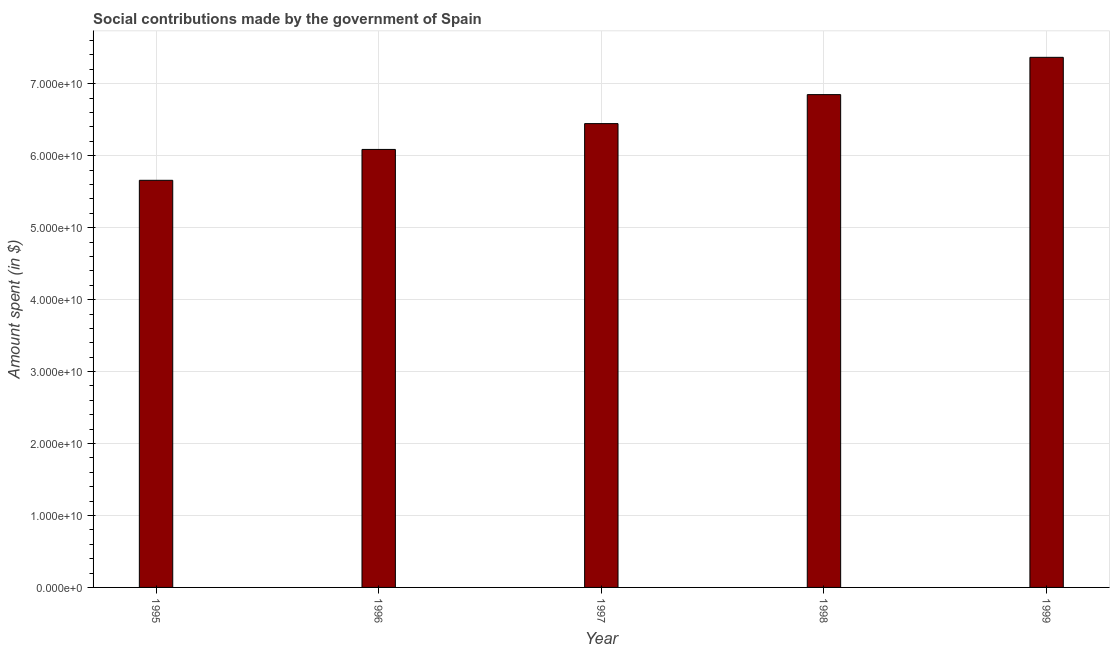What is the title of the graph?
Provide a short and direct response. Social contributions made by the government of Spain. What is the label or title of the Y-axis?
Provide a short and direct response. Amount spent (in $). What is the amount spent in making social contributions in 1998?
Offer a very short reply. 6.85e+1. Across all years, what is the maximum amount spent in making social contributions?
Your answer should be compact. 7.37e+1. Across all years, what is the minimum amount spent in making social contributions?
Your answer should be very brief. 5.66e+1. In which year was the amount spent in making social contributions maximum?
Provide a short and direct response. 1999. In which year was the amount spent in making social contributions minimum?
Keep it short and to the point. 1995. What is the sum of the amount spent in making social contributions?
Keep it short and to the point. 3.24e+11. What is the difference between the amount spent in making social contributions in 1998 and 1999?
Ensure brevity in your answer.  -5.18e+09. What is the average amount spent in making social contributions per year?
Provide a short and direct response. 6.48e+1. What is the median amount spent in making social contributions?
Your answer should be very brief. 6.45e+1. Do a majority of the years between 1999 and 1995 (inclusive) have amount spent in making social contributions greater than 54000000000 $?
Offer a terse response. Yes. What is the ratio of the amount spent in making social contributions in 1995 to that in 1997?
Provide a succinct answer. 0.88. Is the amount spent in making social contributions in 1996 less than that in 1998?
Offer a terse response. Yes. What is the difference between the highest and the second highest amount spent in making social contributions?
Your response must be concise. 5.18e+09. What is the difference between the highest and the lowest amount spent in making social contributions?
Keep it short and to the point. 1.71e+1. In how many years, is the amount spent in making social contributions greater than the average amount spent in making social contributions taken over all years?
Your answer should be very brief. 2. How many bars are there?
Keep it short and to the point. 5. Are all the bars in the graph horizontal?
Your answer should be very brief. No. What is the difference between two consecutive major ticks on the Y-axis?
Provide a short and direct response. 1.00e+1. Are the values on the major ticks of Y-axis written in scientific E-notation?
Your answer should be very brief. Yes. What is the Amount spent (in $) in 1995?
Your answer should be compact. 5.66e+1. What is the Amount spent (in $) of 1996?
Provide a short and direct response. 6.09e+1. What is the Amount spent (in $) in 1997?
Provide a succinct answer. 6.45e+1. What is the Amount spent (in $) in 1998?
Your answer should be compact. 6.85e+1. What is the Amount spent (in $) of 1999?
Offer a very short reply. 7.37e+1. What is the difference between the Amount spent (in $) in 1995 and 1996?
Ensure brevity in your answer.  -4.29e+09. What is the difference between the Amount spent (in $) in 1995 and 1997?
Ensure brevity in your answer.  -7.88e+09. What is the difference between the Amount spent (in $) in 1995 and 1998?
Provide a succinct answer. -1.19e+1. What is the difference between the Amount spent (in $) in 1995 and 1999?
Give a very brief answer. -1.71e+1. What is the difference between the Amount spent (in $) in 1996 and 1997?
Provide a short and direct response. -3.59e+09. What is the difference between the Amount spent (in $) in 1996 and 1998?
Offer a terse response. -7.62e+09. What is the difference between the Amount spent (in $) in 1996 and 1999?
Your answer should be compact. -1.28e+1. What is the difference between the Amount spent (in $) in 1997 and 1998?
Provide a short and direct response. -4.03e+09. What is the difference between the Amount spent (in $) in 1997 and 1999?
Offer a very short reply. -9.21e+09. What is the difference between the Amount spent (in $) in 1998 and 1999?
Provide a succinct answer. -5.18e+09. What is the ratio of the Amount spent (in $) in 1995 to that in 1996?
Provide a succinct answer. 0.93. What is the ratio of the Amount spent (in $) in 1995 to that in 1997?
Your response must be concise. 0.88. What is the ratio of the Amount spent (in $) in 1995 to that in 1998?
Give a very brief answer. 0.83. What is the ratio of the Amount spent (in $) in 1995 to that in 1999?
Give a very brief answer. 0.77. What is the ratio of the Amount spent (in $) in 1996 to that in 1997?
Your answer should be very brief. 0.94. What is the ratio of the Amount spent (in $) in 1996 to that in 1998?
Give a very brief answer. 0.89. What is the ratio of the Amount spent (in $) in 1996 to that in 1999?
Provide a short and direct response. 0.83. What is the ratio of the Amount spent (in $) in 1997 to that in 1998?
Provide a short and direct response. 0.94. What is the ratio of the Amount spent (in $) in 1997 to that in 1999?
Ensure brevity in your answer.  0.88. What is the ratio of the Amount spent (in $) in 1998 to that in 1999?
Keep it short and to the point. 0.93. 